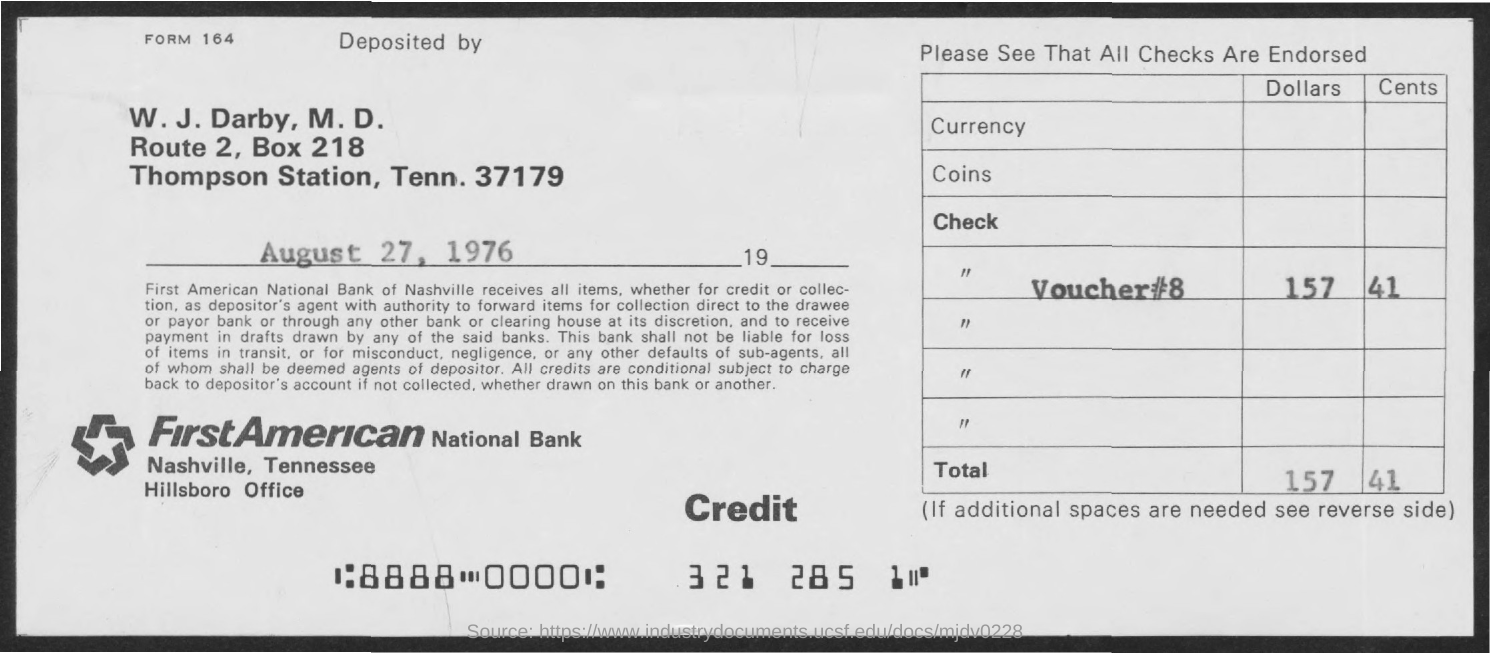Mention a couple of crucial points in this snapshot. On August 27, 1976, the memorandum was dated. The BOX Number is 218. The voucher number is 8. 